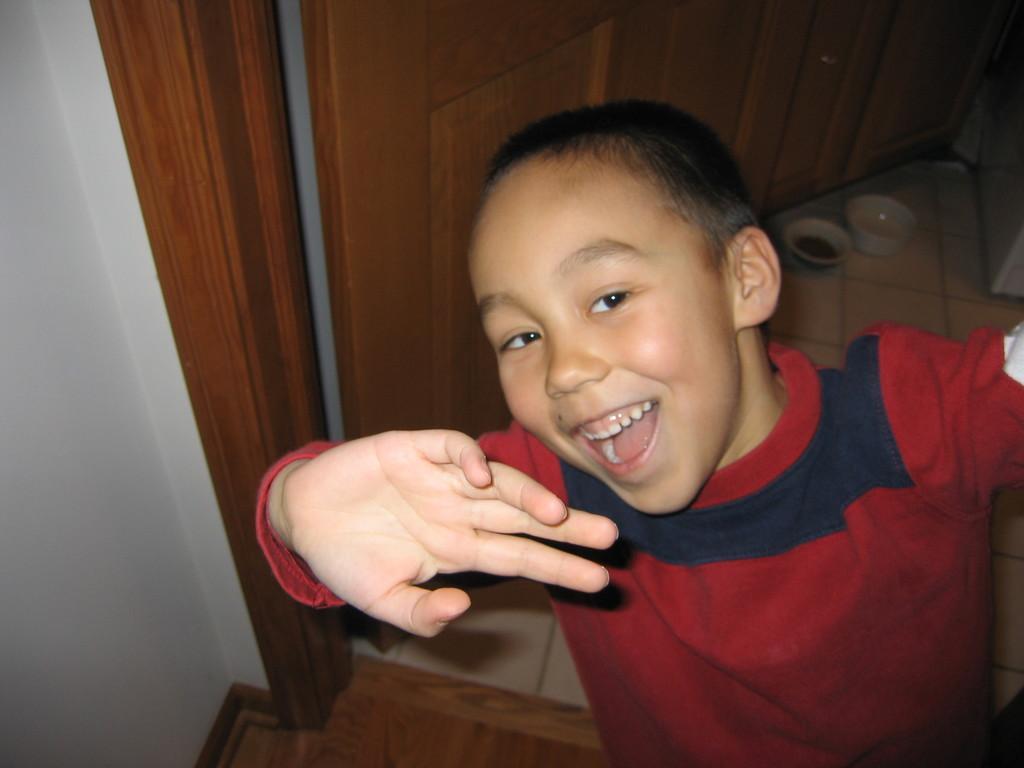Please provide a concise description of this image. In the picture there is a child standing and laughing, behind the child there is a wall and a door present, there are two bowls present on the floor. 